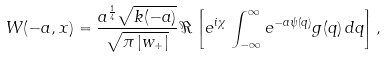<formula> <loc_0><loc_0><loc_500><loc_500>W ( - a , x ) = \frac { a ^ { \frac { 1 } { 4 } } \sqrt { k ( - a ) } } { \sqrt { \pi \, | w _ { + } | } } \, \Re \left [ e ^ { i \chi } \, \int _ { - \infty } ^ { \infty } e ^ { - a \psi ( q ) } g ( q ) \, d q \right ] ,</formula> 